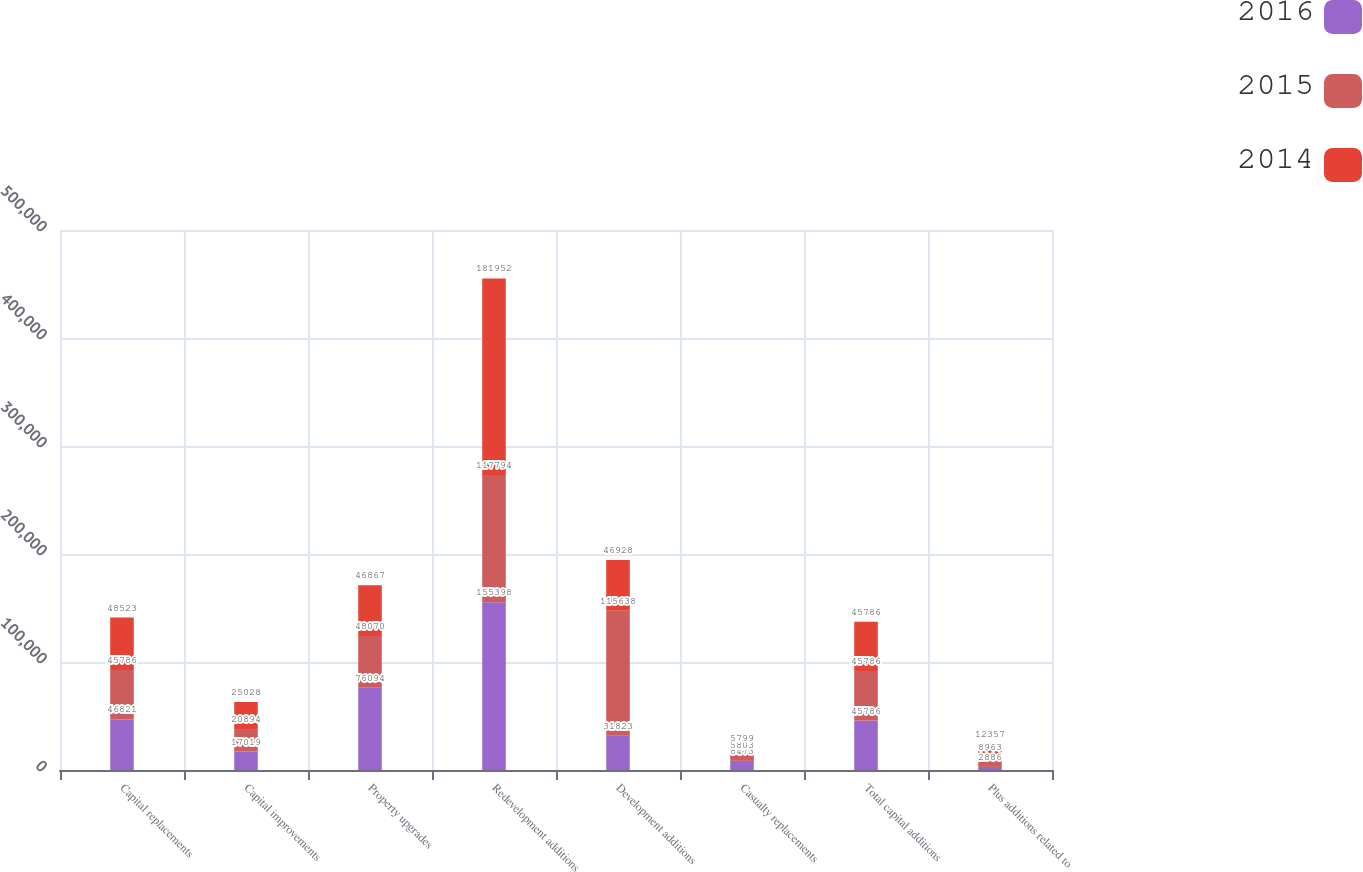Convert chart to OTSL. <chart><loc_0><loc_0><loc_500><loc_500><stacked_bar_chart><ecel><fcel>Capital replacements<fcel>Capital improvements<fcel>Property upgrades<fcel>Redevelopment additions<fcel>Development additions<fcel>Casualty replacements<fcel>Total capital additions<fcel>Plus additions related to<nl><fcel>2016<fcel>46821<fcel>17019<fcel>76094<fcel>155398<fcel>31823<fcel>8473<fcel>45786<fcel>2886<nl><fcel>2015<fcel>45786<fcel>20894<fcel>48070<fcel>117794<fcel>115638<fcel>5803<fcel>45786<fcel>8963<nl><fcel>2014<fcel>48523<fcel>25028<fcel>46867<fcel>181952<fcel>46928<fcel>5799<fcel>45786<fcel>12357<nl></chart> 